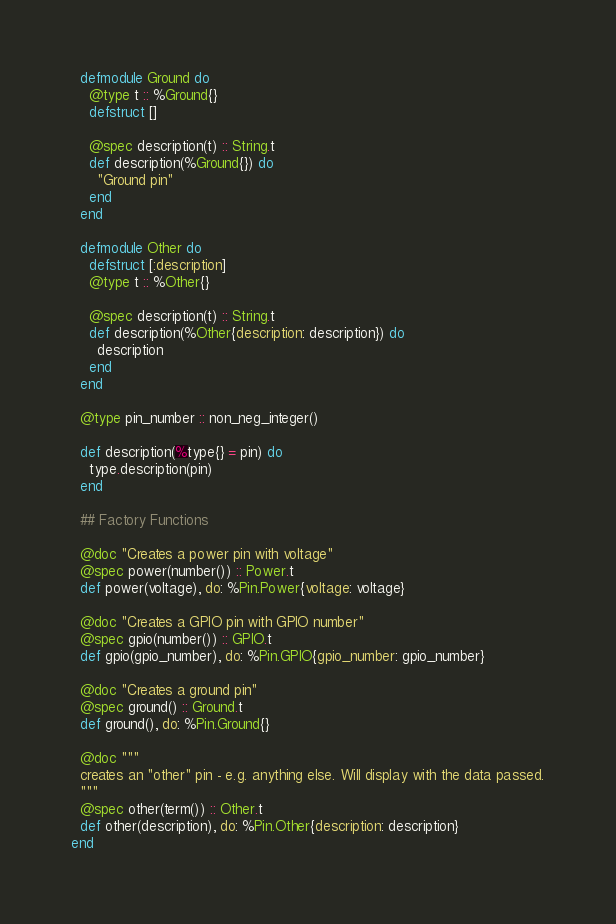<code> <loc_0><loc_0><loc_500><loc_500><_Elixir_>
  defmodule Ground do
    @type t :: %Ground{}
    defstruct []

    @spec description(t) :: String.t
    def description(%Ground{}) do
      "Ground pin"
    end
  end

  defmodule Other do
    defstruct [:description]
    @type t :: %Other{}

    @spec description(t) :: String.t
    def description(%Other{description: description}) do
      description
    end
  end

  @type pin_number :: non_neg_integer()

  def description(%type{} = pin) do
    type.description(pin)
  end

  ## Factory Functions

  @doc "Creates a power pin with voltage"
  @spec power(number()) :: Power.t
  def power(voltage), do: %Pin.Power{voltage: voltage}

  @doc "Creates a GPIO pin with GPIO number"
  @spec gpio(number()) :: GPIO.t
  def gpio(gpio_number), do: %Pin.GPIO{gpio_number: gpio_number}

  @doc "Creates a ground pin"
  @spec ground() :: Ground.t
  def ground(), do: %Pin.Ground{}

  @doc """
  creates an "other" pin - e.g. anything else. Will display with the data passed.
  """
  @spec other(term()) :: Other.t
  def other(description), do: %Pin.Other{description: description}
end
</code> 